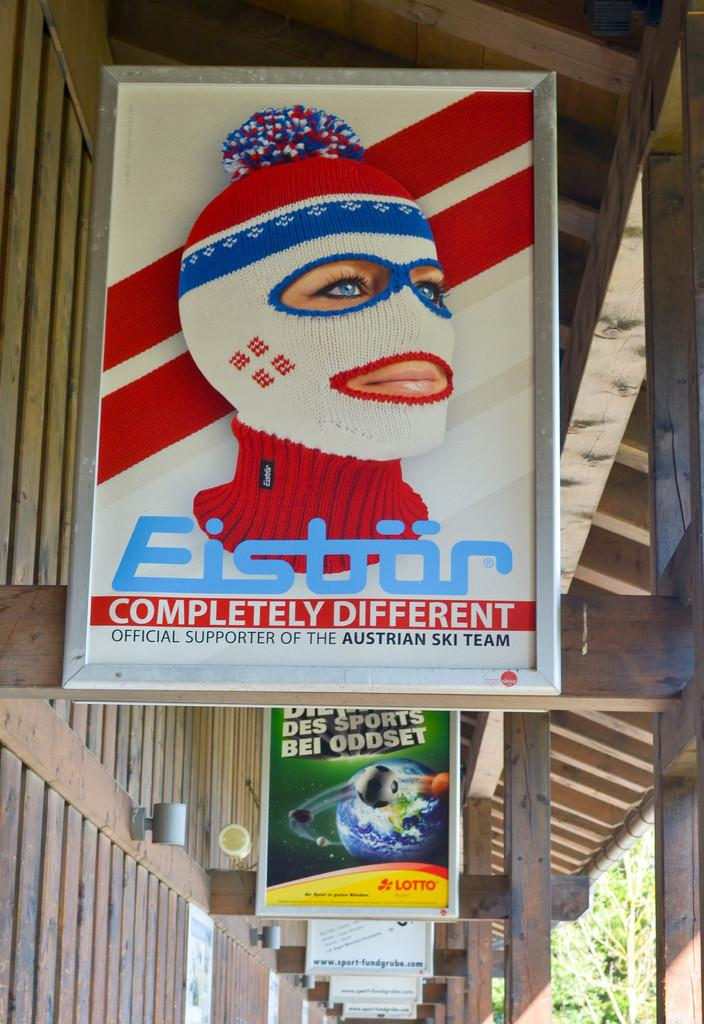<image>
Describe the image concisely. Eistor is an official supporter of the Austrian ski team. 